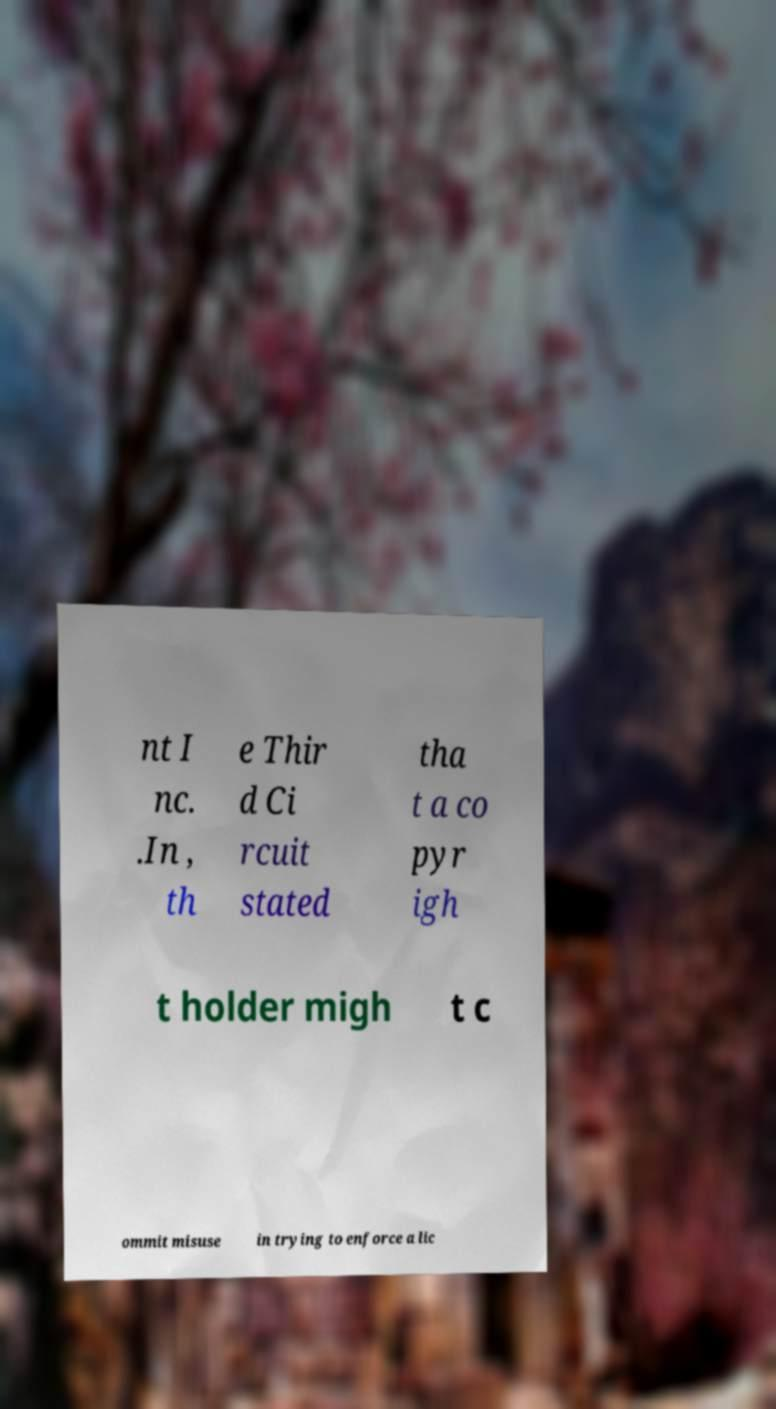Can you accurately transcribe the text from the provided image for me? nt I nc. .In , th e Thir d Ci rcuit stated tha t a co pyr igh t holder migh t c ommit misuse in trying to enforce a lic 